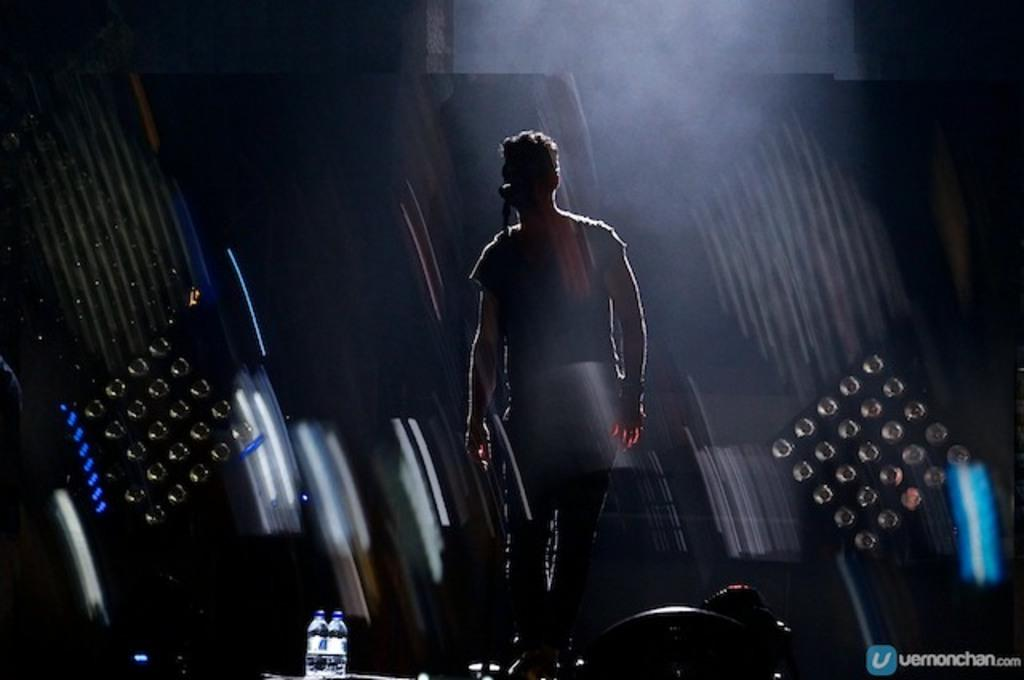Who or what is the main subject in the image? There is a person in the image. What is the person doing in the image? The person is standing in front of a microphone. What can be seen in the background of the image? There are lights visible in the background of the image. What type of hospital unit is visible in the image? There is no hospital unit present in the image; it features a person standing in front of a microphone with lights in the background. How many baskets are visible in the image? There are no baskets present in the image. 